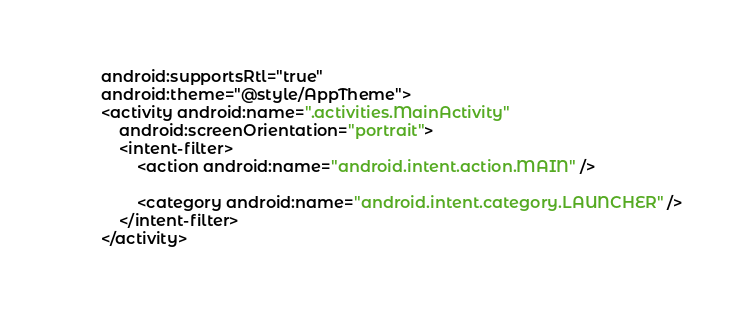Convert code to text. <code><loc_0><loc_0><loc_500><loc_500><_XML_>        android:supportsRtl="true"
        android:theme="@style/AppTheme">
        <activity android:name=".activities.MainActivity"
            android:screenOrientation="portrait">
            <intent-filter>
                <action android:name="android.intent.action.MAIN" />

                <category android:name="android.intent.category.LAUNCHER" />
            </intent-filter>
        </activity>
</code> 